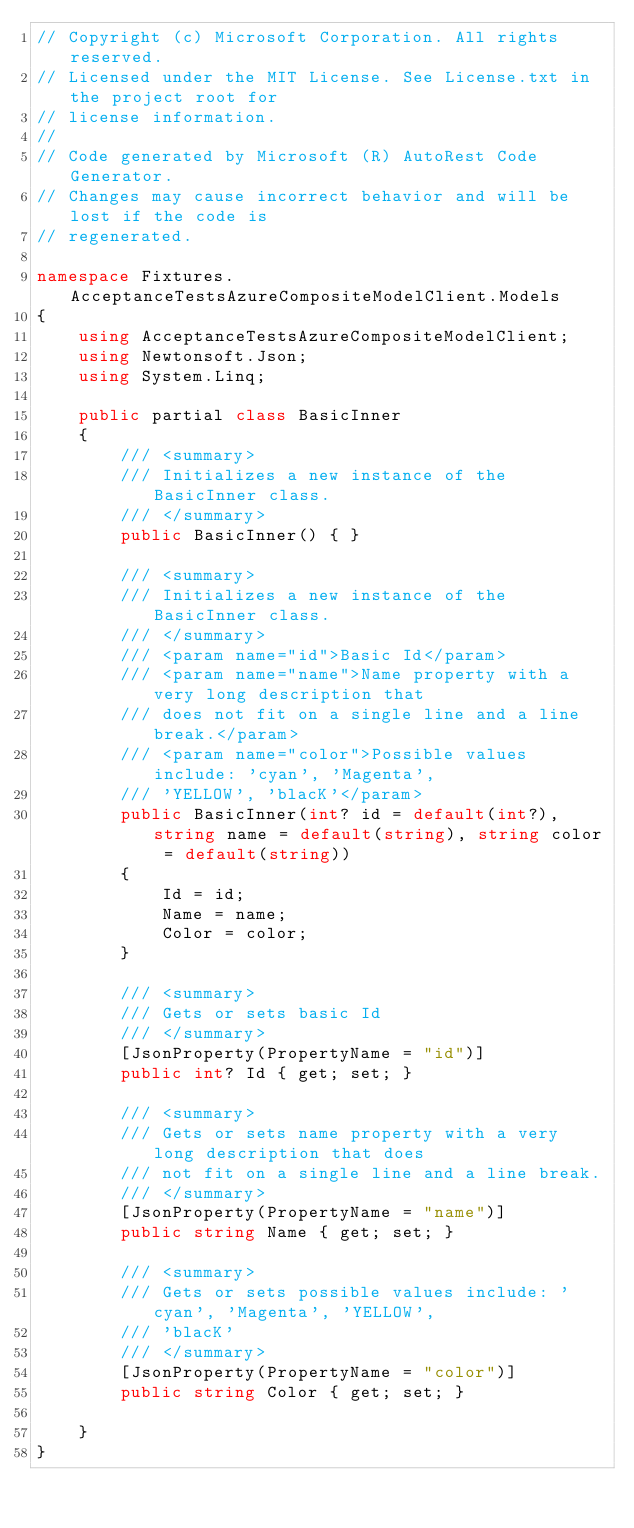Convert code to text. <code><loc_0><loc_0><loc_500><loc_500><_C#_>// Copyright (c) Microsoft Corporation. All rights reserved.
// Licensed under the MIT License. See License.txt in the project root for
// license information.
//
// Code generated by Microsoft (R) AutoRest Code Generator.
// Changes may cause incorrect behavior and will be lost if the code is
// regenerated.

namespace Fixtures.AcceptanceTestsAzureCompositeModelClient.Models
{
    using AcceptanceTestsAzureCompositeModelClient;
    using Newtonsoft.Json;
    using System.Linq;

    public partial class BasicInner
    {
        /// <summary>
        /// Initializes a new instance of the BasicInner class.
        /// </summary>
        public BasicInner() { }

        /// <summary>
        /// Initializes a new instance of the BasicInner class.
        /// </summary>
        /// <param name="id">Basic Id</param>
        /// <param name="name">Name property with a very long description that
        /// does not fit on a single line and a line break.</param>
        /// <param name="color">Possible values include: 'cyan', 'Magenta',
        /// 'YELLOW', 'blacK'</param>
        public BasicInner(int? id = default(int?), string name = default(string), string color = default(string))
        {
            Id = id;
            Name = name;
            Color = color;
        }

        /// <summary>
        /// Gets or sets basic Id
        /// </summary>
        [JsonProperty(PropertyName = "id")]
        public int? Id { get; set; }

        /// <summary>
        /// Gets or sets name property with a very long description that does
        /// not fit on a single line and a line break.
        /// </summary>
        [JsonProperty(PropertyName = "name")]
        public string Name { get; set; }

        /// <summary>
        /// Gets or sets possible values include: 'cyan', 'Magenta', 'YELLOW',
        /// 'blacK'
        /// </summary>
        [JsonProperty(PropertyName = "color")]
        public string Color { get; set; }

    }
}

</code> 